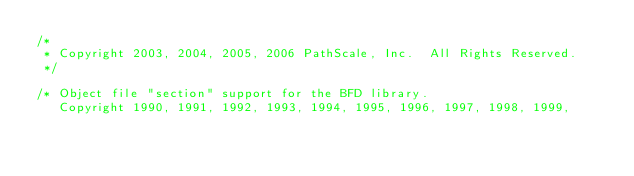<code> <loc_0><loc_0><loc_500><loc_500><_C_>/*
 * Copyright 2003, 2004, 2005, 2006 PathScale, Inc.  All Rights Reserved.
 */

/* Object file "section" support for the BFD library.
   Copyright 1990, 1991, 1992, 1993, 1994, 1995, 1996, 1997, 1998, 1999,</code> 